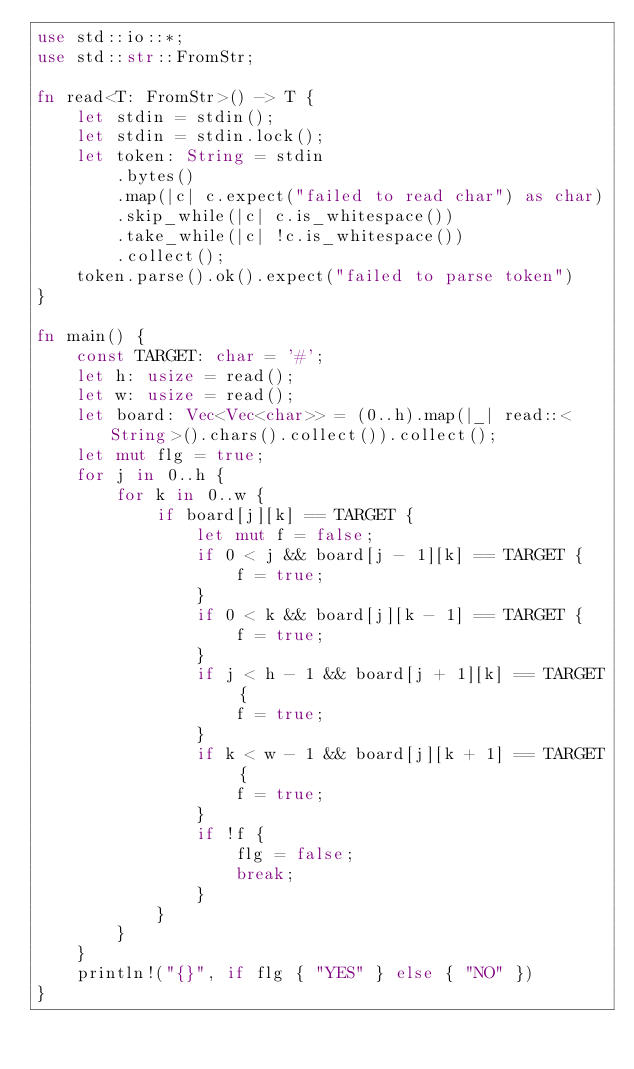<code> <loc_0><loc_0><loc_500><loc_500><_Rust_>use std::io::*;
use std::str::FromStr;

fn read<T: FromStr>() -> T {
    let stdin = stdin();
    let stdin = stdin.lock();
    let token: String = stdin
        .bytes()
        .map(|c| c.expect("failed to read char") as char)
        .skip_while(|c| c.is_whitespace())
        .take_while(|c| !c.is_whitespace())
        .collect();
    token.parse().ok().expect("failed to parse token")
}

fn main() {
    const TARGET: char = '#';
    let h: usize = read();
    let w: usize = read();
    let board: Vec<Vec<char>> = (0..h).map(|_| read::<String>().chars().collect()).collect();
    let mut flg = true;
    for j in 0..h {
        for k in 0..w {
            if board[j][k] == TARGET {
                let mut f = false;
                if 0 < j && board[j - 1][k] == TARGET {
                    f = true;
                }
                if 0 < k && board[j][k - 1] == TARGET {
                    f = true;
                }
                if j < h - 1 && board[j + 1][k] == TARGET {
                    f = true;
                }
                if k < w - 1 && board[j][k + 1] == TARGET {
                    f = true;
                }
                if !f {
                    flg = false;
                    break;
                }
            }
        }
    }
    println!("{}", if flg { "YES" } else { "NO" })
}
</code> 